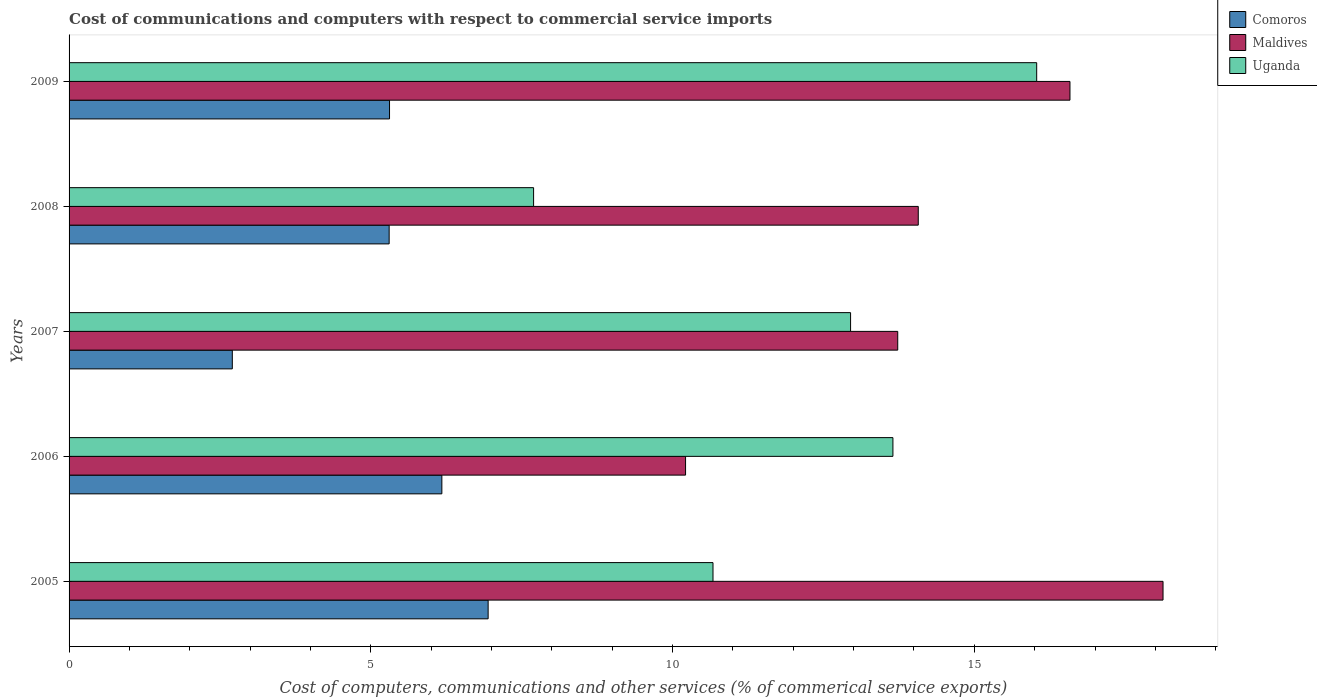How many different coloured bars are there?
Make the answer very short. 3. How many groups of bars are there?
Ensure brevity in your answer.  5. Are the number of bars on each tick of the Y-axis equal?
Make the answer very short. Yes. How many bars are there on the 1st tick from the bottom?
Your answer should be very brief. 3. In how many cases, is the number of bars for a given year not equal to the number of legend labels?
Offer a terse response. 0. What is the cost of communications and computers in Comoros in 2006?
Provide a succinct answer. 6.18. Across all years, what is the maximum cost of communications and computers in Maldives?
Provide a short and direct response. 18.13. Across all years, what is the minimum cost of communications and computers in Maldives?
Provide a short and direct response. 10.22. In which year was the cost of communications and computers in Comoros minimum?
Ensure brevity in your answer.  2007. What is the total cost of communications and computers in Maldives in the graph?
Offer a terse response. 72.73. What is the difference between the cost of communications and computers in Uganda in 2006 and that in 2007?
Your response must be concise. 0.7. What is the difference between the cost of communications and computers in Uganda in 2005 and the cost of communications and computers in Comoros in 2007?
Your answer should be compact. 7.97. What is the average cost of communications and computers in Uganda per year?
Make the answer very short. 12.2. In the year 2005, what is the difference between the cost of communications and computers in Comoros and cost of communications and computers in Maldives?
Provide a succinct answer. -11.18. In how many years, is the cost of communications and computers in Maldives greater than 4 %?
Offer a very short reply. 5. What is the ratio of the cost of communications and computers in Maldives in 2005 to that in 2009?
Provide a succinct answer. 1.09. Is the difference between the cost of communications and computers in Comoros in 2006 and 2008 greater than the difference between the cost of communications and computers in Maldives in 2006 and 2008?
Keep it short and to the point. Yes. What is the difference between the highest and the second highest cost of communications and computers in Comoros?
Your answer should be compact. 0.77. What is the difference between the highest and the lowest cost of communications and computers in Uganda?
Offer a very short reply. 8.34. What does the 3rd bar from the top in 2008 represents?
Your answer should be very brief. Comoros. What does the 1st bar from the bottom in 2006 represents?
Give a very brief answer. Comoros. How many bars are there?
Provide a short and direct response. 15. Does the graph contain any zero values?
Your answer should be compact. No. How many legend labels are there?
Keep it short and to the point. 3. What is the title of the graph?
Your response must be concise. Cost of communications and computers with respect to commercial service imports. Does "World" appear as one of the legend labels in the graph?
Provide a succinct answer. No. What is the label or title of the X-axis?
Offer a very short reply. Cost of computers, communications and other services (% of commerical service exports). What is the label or title of the Y-axis?
Make the answer very short. Years. What is the Cost of computers, communications and other services (% of commerical service exports) of Comoros in 2005?
Ensure brevity in your answer.  6.94. What is the Cost of computers, communications and other services (% of commerical service exports) in Maldives in 2005?
Give a very brief answer. 18.13. What is the Cost of computers, communications and other services (% of commerical service exports) in Uganda in 2005?
Your answer should be compact. 10.67. What is the Cost of computers, communications and other services (% of commerical service exports) in Comoros in 2006?
Make the answer very short. 6.18. What is the Cost of computers, communications and other services (% of commerical service exports) of Maldives in 2006?
Your answer should be very brief. 10.22. What is the Cost of computers, communications and other services (% of commerical service exports) in Uganda in 2006?
Offer a very short reply. 13.65. What is the Cost of computers, communications and other services (% of commerical service exports) of Comoros in 2007?
Your answer should be compact. 2.71. What is the Cost of computers, communications and other services (% of commerical service exports) in Maldives in 2007?
Provide a succinct answer. 13.73. What is the Cost of computers, communications and other services (% of commerical service exports) in Uganda in 2007?
Provide a short and direct response. 12.95. What is the Cost of computers, communications and other services (% of commerical service exports) of Comoros in 2008?
Your answer should be compact. 5.3. What is the Cost of computers, communications and other services (% of commerical service exports) in Maldives in 2008?
Your response must be concise. 14.07. What is the Cost of computers, communications and other services (% of commerical service exports) of Uganda in 2008?
Keep it short and to the point. 7.7. What is the Cost of computers, communications and other services (% of commerical service exports) of Comoros in 2009?
Offer a very short reply. 5.31. What is the Cost of computers, communications and other services (% of commerical service exports) in Maldives in 2009?
Your answer should be very brief. 16.59. What is the Cost of computers, communications and other services (% of commerical service exports) in Uganda in 2009?
Offer a very short reply. 16.03. Across all years, what is the maximum Cost of computers, communications and other services (% of commerical service exports) in Comoros?
Give a very brief answer. 6.94. Across all years, what is the maximum Cost of computers, communications and other services (% of commerical service exports) in Maldives?
Offer a terse response. 18.13. Across all years, what is the maximum Cost of computers, communications and other services (% of commerical service exports) in Uganda?
Your response must be concise. 16.03. Across all years, what is the minimum Cost of computers, communications and other services (% of commerical service exports) of Comoros?
Provide a short and direct response. 2.71. Across all years, what is the minimum Cost of computers, communications and other services (% of commerical service exports) of Maldives?
Your answer should be very brief. 10.22. Across all years, what is the minimum Cost of computers, communications and other services (% of commerical service exports) in Uganda?
Your answer should be compact. 7.7. What is the total Cost of computers, communications and other services (% of commerical service exports) of Comoros in the graph?
Offer a terse response. 26.44. What is the total Cost of computers, communications and other services (% of commerical service exports) in Maldives in the graph?
Offer a terse response. 72.73. What is the total Cost of computers, communications and other services (% of commerical service exports) of Uganda in the graph?
Provide a succinct answer. 61. What is the difference between the Cost of computers, communications and other services (% of commerical service exports) in Comoros in 2005 and that in 2006?
Offer a very short reply. 0.77. What is the difference between the Cost of computers, communications and other services (% of commerical service exports) in Maldives in 2005 and that in 2006?
Your answer should be compact. 7.91. What is the difference between the Cost of computers, communications and other services (% of commerical service exports) of Uganda in 2005 and that in 2006?
Your answer should be compact. -2.98. What is the difference between the Cost of computers, communications and other services (% of commerical service exports) in Comoros in 2005 and that in 2007?
Provide a succinct answer. 4.24. What is the difference between the Cost of computers, communications and other services (% of commerical service exports) in Maldives in 2005 and that in 2007?
Provide a succinct answer. 4.4. What is the difference between the Cost of computers, communications and other services (% of commerical service exports) of Uganda in 2005 and that in 2007?
Make the answer very short. -2.28. What is the difference between the Cost of computers, communications and other services (% of commerical service exports) of Comoros in 2005 and that in 2008?
Offer a very short reply. 1.64. What is the difference between the Cost of computers, communications and other services (% of commerical service exports) in Maldives in 2005 and that in 2008?
Give a very brief answer. 4.06. What is the difference between the Cost of computers, communications and other services (% of commerical service exports) of Uganda in 2005 and that in 2008?
Ensure brevity in your answer.  2.97. What is the difference between the Cost of computers, communications and other services (% of commerical service exports) in Comoros in 2005 and that in 2009?
Offer a terse response. 1.63. What is the difference between the Cost of computers, communications and other services (% of commerical service exports) of Maldives in 2005 and that in 2009?
Ensure brevity in your answer.  1.54. What is the difference between the Cost of computers, communications and other services (% of commerical service exports) of Uganda in 2005 and that in 2009?
Your answer should be very brief. -5.36. What is the difference between the Cost of computers, communications and other services (% of commerical service exports) in Comoros in 2006 and that in 2007?
Provide a succinct answer. 3.47. What is the difference between the Cost of computers, communications and other services (% of commerical service exports) of Maldives in 2006 and that in 2007?
Ensure brevity in your answer.  -3.52. What is the difference between the Cost of computers, communications and other services (% of commerical service exports) of Uganda in 2006 and that in 2007?
Make the answer very short. 0.7. What is the difference between the Cost of computers, communications and other services (% of commerical service exports) of Comoros in 2006 and that in 2008?
Keep it short and to the point. 0.87. What is the difference between the Cost of computers, communications and other services (% of commerical service exports) of Maldives in 2006 and that in 2008?
Provide a short and direct response. -3.86. What is the difference between the Cost of computers, communications and other services (% of commerical service exports) of Uganda in 2006 and that in 2008?
Your response must be concise. 5.95. What is the difference between the Cost of computers, communications and other services (% of commerical service exports) of Comoros in 2006 and that in 2009?
Ensure brevity in your answer.  0.87. What is the difference between the Cost of computers, communications and other services (% of commerical service exports) of Maldives in 2006 and that in 2009?
Offer a terse response. -6.37. What is the difference between the Cost of computers, communications and other services (% of commerical service exports) of Uganda in 2006 and that in 2009?
Your response must be concise. -2.38. What is the difference between the Cost of computers, communications and other services (% of commerical service exports) in Comoros in 2007 and that in 2008?
Provide a succinct answer. -2.6. What is the difference between the Cost of computers, communications and other services (% of commerical service exports) of Maldives in 2007 and that in 2008?
Keep it short and to the point. -0.34. What is the difference between the Cost of computers, communications and other services (% of commerical service exports) of Uganda in 2007 and that in 2008?
Ensure brevity in your answer.  5.25. What is the difference between the Cost of computers, communications and other services (% of commerical service exports) in Comoros in 2007 and that in 2009?
Your answer should be very brief. -2.6. What is the difference between the Cost of computers, communications and other services (% of commerical service exports) of Maldives in 2007 and that in 2009?
Keep it short and to the point. -2.85. What is the difference between the Cost of computers, communications and other services (% of commerical service exports) of Uganda in 2007 and that in 2009?
Keep it short and to the point. -3.08. What is the difference between the Cost of computers, communications and other services (% of commerical service exports) of Comoros in 2008 and that in 2009?
Make the answer very short. -0.01. What is the difference between the Cost of computers, communications and other services (% of commerical service exports) of Maldives in 2008 and that in 2009?
Make the answer very short. -2.51. What is the difference between the Cost of computers, communications and other services (% of commerical service exports) of Uganda in 2008 and that in 2009?
Provide a succinct answer. -8.34. What is the difference between the Cost of computers, communications and other services (% of commerical service exports) in Comoros in 2005 and the Cost of computers, communications and other services (% of commerical service exports) in Maldives in 2006?
Make the answer very short. -3.27. What is the difference between the Cost of computers, communications and other services (% of commerical service exports) in Comoros in 2005 and the Cost of computers, communications and other services (% of commerical service exports) in Uganda in 2006?
Offer a terse response. -6.71. What is the difference between the Cost of computers, communications and other services (% of commerical service exports) of Maldives in 2005 and the Cost of computers, communications and other services (% of commerical service exports) of Uganda in 2006?
Provide a short and direct response. 4.48. What is the difference between the Cost of computers, communications and other services (% of commerical service exports) of Comoros in 2005 and the Cost of computers, communications and other services (% of commerical service exports) of Maldives in 2007?
Your response must be concise. -6.79. What is the difference between the Cost of computers, communications and other services (% of commerical service exports) of Comoros in 2005 and the Cost of computers, communications and other services (% of commerical service exports) of Uganda in 2007?
Offer a terse response. -6.01. What is the difference between the Cost of computers, communications and other services (% of commerical service exports) in Maldives in 2005 and the Cost of computers, communications and other services (% of commerical service exports) in Uganda in 2007?
Give a very brief answer. 5.18. What is the difference between the Cost of computers, communications and other services (% of commerical service exports) in Comoros in 2005 and the Cost of computers, communications and other services (% of commerical service exports) in Maldives in 2008?
Keep it short and to the point. -7.13. What is the difference between the Cost of computers, communications and other services (% of commerical service exports) of Comoros in 2005 and the Cost of computers, communications and other services (% of commerical service exports) of Uganda in 2008?
Give a very brief answer. -0.75. What is the difference between the Cost of computers, communications and other services (% of commerical service exports) in Maldives in 2005 and the Cost of computers, communications and other services (% of commerical service exports) in Uganda in 2008?
Ensure brevity in your answer.  10.43. What is the difference between the Cost of computers, communications and other services (% of commerical service exports) of Comoros in 2005 and the Cost of computers, communications and other services (% of commerical service exports) of Maldives in 2009?
Provide a succinct answer. -9.64. What is the difference between the Cost of computers, communications and other services (% of commerical service exports) of Comoros in 2005 and the Cost of computers, communications and other services (% of commerical service exports) of Uganda in 2009?
Make the answer very short. -9.09. What is the difference between the Cost of computers, communications and other services (% of commerical service exports) in Maldives in 2005 and the Cost of computers, communications and other services (% of commerical service exports) in Uganda in 2009?
Your response must be concise. 2.09. What is the difference between the Cost of computers, communications and other services (% of commerical service exports) in Comoros in 2006 and the Cost of computers, communications and other services (% of commerical service exports) in Maldives in 2007?
Your answer should be compact. -7.55. What is the difference between the Cost of computers, communications and other services (% of commerical service exports) in Comoros in 2006 and the Cost of computers, communications and other services (% of commerical service exports) in Uganda in 2007?
Give a very brief answer. -6.77. What is the difference between the Cost of computers, communications and other services (% of commerical service exports) of Maldives in 2006 and the Cost of computers, communications and other services (% of commerical service exports) of Uganda in 2007?
Keep it short and to the point. -2.73. What is the difference between the Cost of computers, communications and other services (% of commerical service exports) in Comoros in 2006 and the Cost of computers, communications and other services (% of commerical service exports) in Maldives in 2008?
Your response must be concise. -7.89. What is the difference between the Cost of computers, communications and other services (% of commerical service exports) in Comoros in 2006 and the Cost of computers, communications and other services (% of commerical service exports) in Uganda in 2008?
Offer a very short reply. -1.52. What is the difference between the Cost of computers, communications and other services (% of commerical service exports) of Maldives in 2006 and the Cost of computers, communications and other services (% of commerical service exports) of Uganda in 2008?
Offer a terse response. 2.52. What is the difference between the Cost of computers, communications and other services (% of commerical service exports) of Comoros in 2006 and the Cost of computers, communications and other services (% of commerical service exports) of Maldives in 2009?
Provide a succinct answer. -10.41. What is the difference between the Cost of computers, communications and other services (% of commerical service exports) of Comoros in 2006 and the Cost of computers, communications and other services (% of commerical service exports) of Uganda in 2009?
Offer a very short reply. -9.86. What is the difference between the Cost of computers, communications and other services (% of commerical service exports) in Maldives in 2006 and the Cost of computers, communications and other services (% of commerical service exports) in Uganda in 2009?
Provide a short and direct response. -5.82. What is the difference between the Cost of computers, communications and other services (% of commerical service exports) of Comoros in 2007 and the Cost of computers, communications and other services (% of commerical service exports) of Maldives in 2008?
Offer a very short reply. -11.37. What is the difference between the Cost of computers, communications and other services (% of commerical service exports) in Comoros in 2007 and the Cost of computers, communications and other services (% of commerical service exports) in Uganda in 2008?
Provide a succinct answer. -4.99. What is the difference between the Cost of computers, communications and other services (% of commerical service exports) of Maldives in 2007 and the Cost of computers, communications and other services (% of commerical service exports) of Uganda in 2008?
Provide a succinct answer. 6.03. What is the difference between the Cost of computers, communications and other services (% of commerical service exports) of Comoros in 2007 and the Cost of computers, communications and other services (% of commerical service exports) of Maldives in 2009?
Provide a short and direct response. -13.88. What is the difference between the Cost of computers, communications and other services (% of commerical service exports) in Comoros in 2007 and the Cost of computers, communications and other services (% of commerical service exports) in Uganda in 2009?
Your answer should be very brief. -13.33. What is the difference between the Cost of computers, communications and other services (% of commerical service exports) of Maldives in 2007 and the Cost of computers, communications and other services (% of commerical service exports) of Uganda in 2009?
Provide a short and direct response. -2.3. What is the difference between the Cost of computers, communications and other services (% of commerical service exports) of Comoros in 2008 and the Cost of computers, communications and other services (% of commerical service exports) of Maldives in 2009?
Your response must be concise. -11.28. What is the difference between the Cost of computers, communications and other services (% of commerical service exports) of Comoros in 2008 and the Cost of computers, communications and other services (% of commerical service exports) of Uganda in 2009?
Offer a terse response. -10.73. What is the difference between the Cost of computers, communications and other services (% of commerical service exports) of Maldives in 2008 and the Cost of computers, communications and other services (% of commerical service exports) of Uganda in 2009?
Your answer should be very brief. -1.96. What is the average Cost of computers, communications and other services (% of commerical service exports) in Comoros per year?
Give a very brief answer. 5.29. What is the average Cost of computers, communications and other services (% of commerical service exports) in Maldives per year?
Offer a terse response. 14.55. What is the average Cost of computers, communications and other services (% of commerical service exports) in Uganda per year?
Provide a short and direct response. 12.2. In the year 2005, what is the difference between the Cost of computers, communications and other services (% of commerical service exports) of Comoros and Cost of computers, communications and other services (% of commerical service exports) of Maldives?
Your response must be concise. -11.18. In the year 2005, what is the difference between the Cost of computers, communications and other services (% of commerical service exports) of Comoros and Cost of computers, communications and other services (% of commerical service exports) of Uganda?
Ensure brevity in your answer.  -3.73. In the year 2005, what is the difference between the Cost of computers, communications and other services (% of commerical service exports) of Maldives and Cost of computers, communications and other services (% of commerical service exports) of Uganda?
Offer a terse response. 7.46. In the year 2006, what is the difference between the Cost of computers, communications and other services (% of commerical service exports) of Comoros and Cost of computers, communications and other services (% of commerical service exports) of Maldives?
Your answer should be compact. -4.04. In the year 2006, what is the difference between the Cost of computers, communications and other services (% of commerical service exports) in Comoros and Cost of computers, communications and other services (% of commerical service exports) in Uganda?
Offer a terse response. -7.47. In the year 2006, what is the difference between the Cost of computers, communications and other services (% of commerical service exports) of Maldives and Cost of computers, communications and other services (% of commerical service exports) of Uganda?
Make the answer very short. -3.44. In the year 2007, what is the difference between the Cost of computers, communications and other services (% of commerical service exports) in Comoros and Cost of computers, communications and other services (% of commerical service exports) in Maldives?
Your answer should be very brief. -11.03. In the year 2007, what is the difference between the Cost of computers, communications and other services (% of commerical service exports) of Comoros and Cost of computers, communications and other services (% of commerical service exports) of Uganda?
Offer a terse response. -10.24. In the year 2007, what is the difference between the Cost of computers, communications and other services (% of commerical service exports) of Maldives and Cost of computers, communications and other services (% of commerical service exports) of Uganda?
Your response must be concise. 0.78. In the year 2008, what is the difference between the Cost of computers, communications and other services (% of commerical service exports) in Comoros and Cost of computers, communications and other services (% of commerical service exports) in Maldives?
Keep it short and to the point. -8.77. In the year 2008, what is the difference between the Cost of computers, communications and other services (% of commerical service exports) of Comoros and Cost of computers, communications and other services (% of commerical service exports) of Uganda?
Your answer should be very brief. -2.39. In the year 2008, what is the difference between the Cost of computers, communications and other services (% of commerical service exports) of Maldives and Cost of computers, communications and other services (% of commerical service exports) of Uganda?
Provide a short and direct response. 6.37. In the year 2009, what is the difference between the Cost of computers, communications and other services (% of commerical service exports) in Comoros and Cost of computers, communications and other services (% of commerical service exports) in Maldives?
Offer a terse response. -11.28. In the year 2009, what is the difference between the Cost of computers, communications and other services (% of commerical service exports) in Comoros and Cost of computers, communications and other services (% of commerical service exports) in Uganda?
Offer a terse response. -10.72. In the year 2009, what is the difference between the Cost of computers, communications and other services (% of commerical service exports) in Maldives and Cost of computers, communications and other services (% of commerical service exports) in Uganda?
Offer a very short reply. 0.55. What is the ratio of the Cost of computers, communications and other services (% of commerical service exports) in Comoros in 2005 to that in 2006?
Offer a very short reply. 1.12. What is the ratio of the Cost of computers, communications and other services (% of commerical service exports) in Maldives in 2005 to that in 2006?
Keep it short and to the point. 1.77. What is the ratio of the Cost of computers, communications and other services (% of commerical service exports) of Uganda in 2005 to that in 2006?
Give a very brief answer. 0.78. What is the ratio of the Cost of computers, communications and other services (% of commerical service exports) in Comoros in 2005 to that in 2007?
Offer a very short reply. 2.57. What is the ratio of the Cost of computers, communications and other services (% of commerical service exports) of Maldives in 2005 to that in 2007?
Your response must be concise. 1.32. What is the ratio of the Cost of computers, communications and other services (% of commerical service exports) in Uganda in 2005 to that in 2007?
Offer a terse response. 0.82. What is the ratio of the Cost of computers, communications and other services (% of commerical service exports) of Comoros in 2005 to that in 2008?
Your answer should be very brief. 1.31. What is the ratio of the Cost of computers, communications and other services (% of commerical service exports) in Maldives in 2005 to that in 2008?
Provide a short and direct response. 1.29. What is the ratio of the Cost of computers, communications and other services (% of commerical service exports) in Uganda in 2005 to that in 2008?
Make the answer very short. 1.39. What is the ratio of the Cost of computers, communications and other services (% of commerical service exports) in Comoros in 2005 to that in 2009?
Your answer should be very brief. 1.31. What is the ratio of the Cost of computers, communications and other services (% of commerical service exports) of Maldives in 2005 to that in 2009?
Give a very brief answer. 1.09. What is the ratio of the Cost of computers, communications and other services (% of commerical service exports) of Uganda in 2005 to that in 2009?
Your answer should be very brief. 0.67. What is the ratio of the Cost of computers, communications and other services (% of commerical service exports) in Comoros in 2006 to that in 2007?
Offer a terse response. 2.28. What is the ratio of the Cost of computers, communications and other services (% of commerical service exports) in Maldives in 2006 to that in 2007?
Your answer should be very brief. 0.74. What is the ratio of the Cost of computers, communications and other services (% of commerical service exports) in Uganda in 2006 to that in 2007?
Your response must be concise. 1.05. What is the ratio of the Cost of computers, communications and other services (% of commerical service exports) of Comoros in 2006 to that in 2008?
Your answer should be compact. 1.16. What is the ratio of the Cost of computers, communications and other services (% of commerical service exports) of Maldives in 2006 to that in 2008?
Offer a very short reply. 0.73. What is the ratio of the Cost of computers, communications and other services (% of commerical service exports) in Uganda in 2006 to that in 2008?
Provide a succinct answer. 1.77. What is the ratio of the Cost of computers, communications and other services (% of commerical service exports) of Comoros in 2006 to that in 2009?
Make the answer very short. 1.16. What is the ratio of the Cost of computers, communications and other services (% of commerical service exports) in Maldives in 2006 to that in 2009?
Offer a terse response. 0.62. What is the ratio of the Cost of computers, communications and other services (% of commerical service exports) of Uganda in 2006 to that in 2009?
Offer a very short reply. 0.85. What is the ratio of the Cost of computers, communications and other services (% of commerical service exports) in Comoros in 2007 to that in 2008?
Offer a terse response. 0.51. What is the ratio of the Cost of computers, communications and other services (% of commerical service exports) of Maldives in 2007 to that in 2008?
Give a very brief answer. 0.98. What is the ratio of the Cost of computers, communications and other services (% of commerical service exports) in Uganda in 2007 to that in 2008?
Your answer should be compact. 1.68. What is the ratio of the Cost of computers, communications and other services (% of commerical service exports) in Comoros in 2007 to that in 2009?
Your answer should be very brief. 0.51. What is the ratio of the Cost of computers, communications and other services (% of commerical service exports) of Maldives in 2007 to that in 2009?
Provide a short and direct response. 0.83. What is the ratio of the Cost of computers, communications and other services (% of commerical service exports) in Uganda in 2007 to that in 2009?
Offer a very short reply. 0.81. What is the ratio of the Cost of computers, communications and other services (% of commerical service exports) of Comoros in 2008 to that in 2009?
Make the answer very short. 1. What is the ratio of the Cost of computers, communications and other services (% of commerical service exports) of Maldives in 2008 to that in 2009?
Make the answer very short. 0.85. What is the ratio of the Cost of computers, communications and other services (% of commerical service exports) in Uganda in 2008 to that in 2009?
Offer a very short reply. 0.48. What is the difference between the highest and the second highest Cost of computers, communications and other services (% of commerical service exports) in Comoros?
Provide a short and direct response. 0.77. What is the difference between the highest and the second highest Cost of computers, communications and other services (% of commerical service exports) in Maldives?
Your answer should be very brief. 1.54. What is the difference between the highest and the second highest Cost of computers, communications and other services (% of commerical service exports) in Uganda?
Your response must be concise. 2.38. What is the difference between the highest and the lowest Cost of computers, communications and other services (% of commerical service exports) in Comoros?
Offer a very short reply. 4.24. What is the difference between the highest and the lowest Cost of computers, communications and other services (% of commerical service exports) of Maldives?
Offer a terse response. 7.91. What is the difference between the highest and the lowest Cost of computers, communications and other services (% of commerical service exports) of Uganda?
Your answer should be very brief. 8.34. 